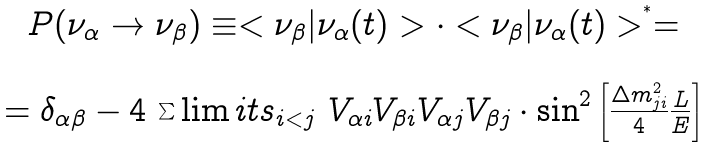Convert formula to latex. <formula><loc_0><loc_0><loc_500><loc_500>\begin{array} { c } P ( \nu _ { \alpha } \rightarrow \nu _ { \beta } ) \equiv < \nu _ { \beta } | \nu _ { \alpha } ( t ) > \cdot < \nu _ { \beta } | \nu _ { \alpha } ( t ) > ^ { ^ { * } } = \\ \\ = \delta _ { \alpha \beta } - 4 \ { \sum \lim i t s _ { i < j } \ } V _ { \alpha i } V _ { \beta i } V _ { \alpha j } V _ { \beta j } \cdot \sin ^ { 2 } \left [ { \frac { \Delta m _ { j i } ^ { 2 } } 4 } { \frac { L } { E } } \right ] \end{array}</formula> 